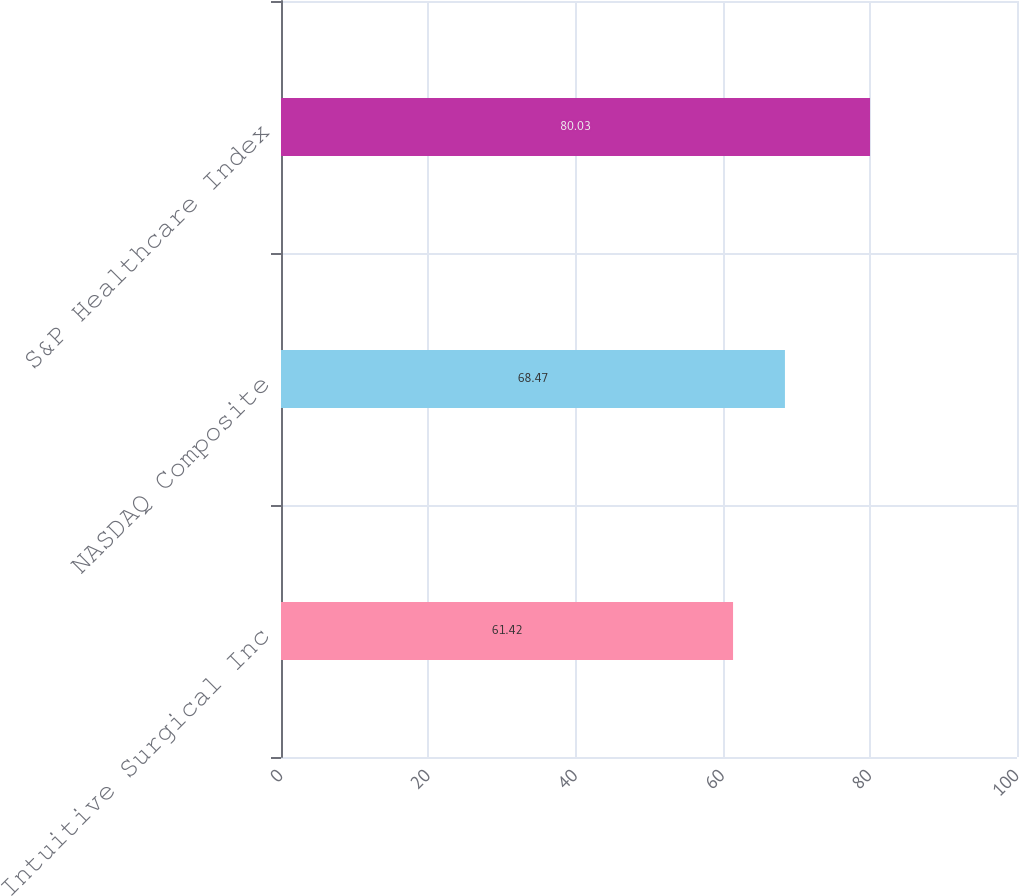<chart> <loc_0><loc_0><loc_500><loc_500><bar_chart><fcel>Intuitive Surgical Inc<fcel>NASDAQ Composite<fcel>S&P Healthcare Index<nl><fcel>61.42<fcel>68.47<fcel>80.03<nl></chart> 